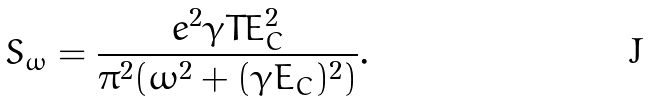Convert formula to latex. <formula><loc_0><loc_0><loc_500><loc_500>S _ { \omega } = \frac { e ^ { 2 } \gamma T E _ { C } ^ { 2 } } { \pi ^ { 2 } ( \omega ^ { 2 } + ( \gamma E _ { C } ) ^ { 2 } ) } .</formula> 